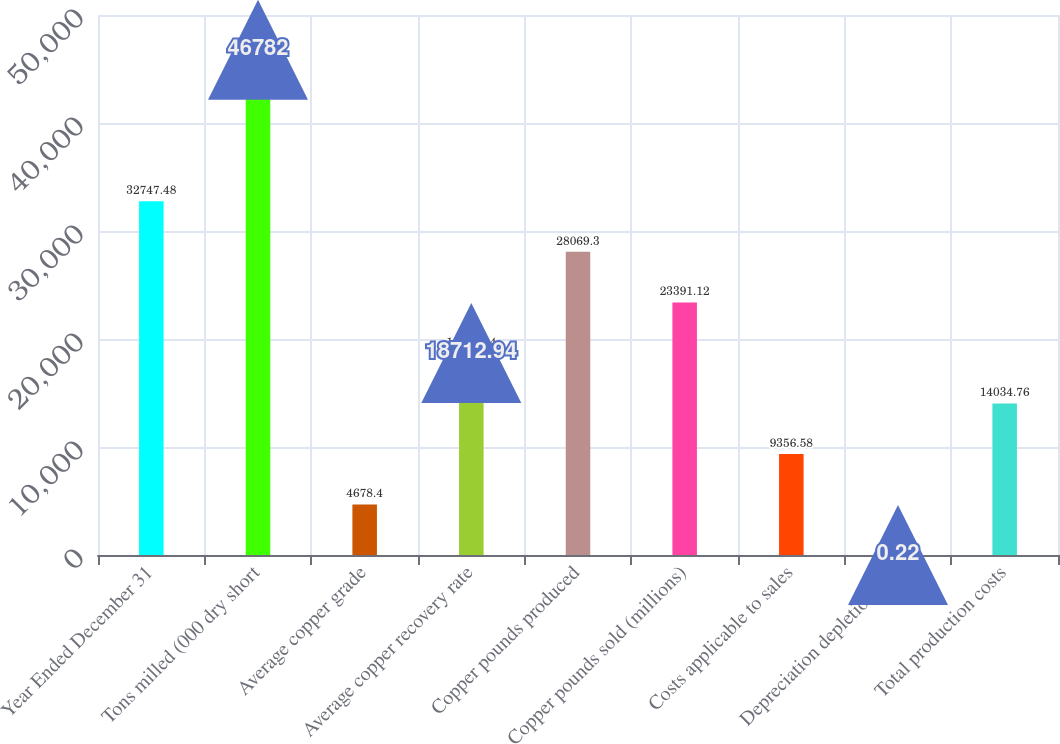Convert chart. <chart><loc_0><loc_0><loc_500><loc_500><bar_chart><fcel>Year Ended December 31<fcel>Tons milled (000 dry short<fcel>Average copper grade<fcel>Average copper recovery rate<fcel>Copper pounds produced<fcel>Copper pounds sold (millions)<fcel>Costs applicable to sales<fcel>Depreciation depletion and<fcel>Total production costs<nl><fcel>32747.5<fcel>46782<fcel>4678.4<fcel>18712.9<fcel>28069.3<fcel>23391.1<fcel>9356.58<fcel>0.22<fcel>14034.8<nl></chart> 